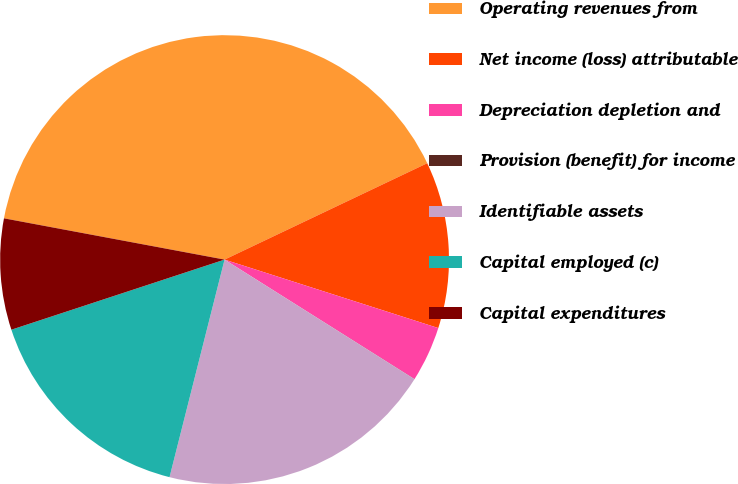Convert chart. <chart><loc_0><loc_0><loc_500><loc_500><pie_chart><fcel>Operating revenues from<fcel>Net income (loss) attributable<fcel>Depreciation depletion and<fcel>Provision (benefit) for income<fcel>Identifiable assets<fcel>Capital employed (c)<fcel>Capital expenditures<nl><fcel>39.99%<fcel>12.0%<fcel>4.0%<fcel>0.01%<fcel>20.0%<fcel>16.0%<fcel>8.0%<nl></chart> 